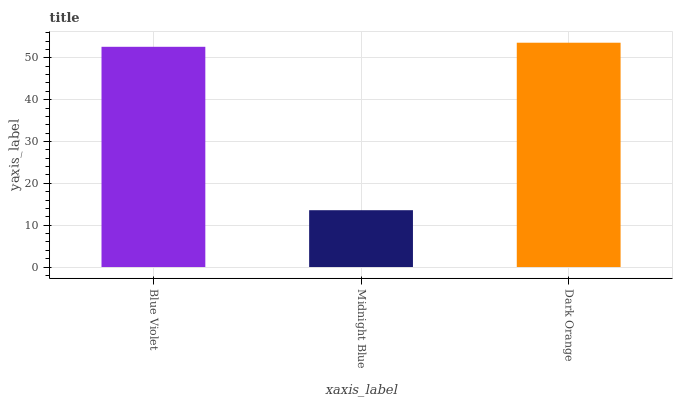Is Midnight Blue the minimum?
Answer yes or no. Yes. Is Dark Orange the maximum?
Answer yes or no. Yes. Is Dark Orange the minimum?
Answer yes or no. No. Is Midnight Blue the maximum?
Answer yes or no. No. Is Dark Orange greater than Midnight Blue?
Answer yes or no. Yes. Is Midnight Blue less than Dark Orange?
Answer yes or no. Yes. Is Midnight Blue greater than Dark Orange?
Answer yes or no. No. Is Dark Orange less than Midnight Blue?
Answer yes or no. No. Is Blue Violet the high median?
Answer yes or no. Yes. Is Blue Violet the low median?
Answer yes or no. Yes. Is Dark Orange the high median?
Answer yes or no. No. Is Midnight Blue the low median?
Answer yes or no. No. 